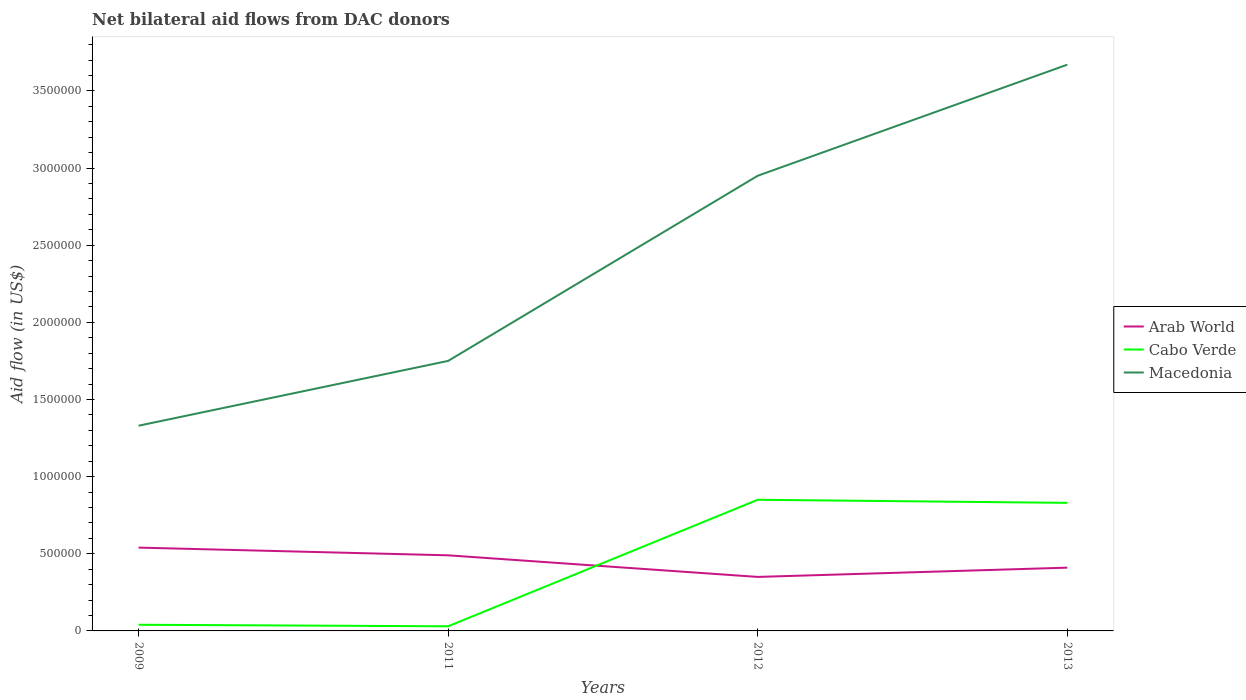How many different coloured lines are there?
Your response must be concise. 3. Does the line corresponding to Cabo Verde intersect with the line corresponding to Arab World?
Keep it short and to the point. Yes. Is the number of lines equal to the number of legend labels?
Your response must be concise. Yes. Across all years, what is the maximum net bilateral aid flow in Macedonia?
Offer a terse response. 1.33e+06. What is the total net bilateral aid flow in Macedonia in the graph?
Your response must be concise. -2.34e+06. What is the difference between the highest and the second highest net bilateral aid flow in Cabo Verde?
Keep it short and to the point. 8.20e+05. Is the net bilateral aid flow in Cabo Verde strictly greater than the net bilateral aid flow in Arab World over the years?
Give a very brief answer. No. How many lines are there?
Provide a succinct answer. 3. How many years are there in the graph?
Provide a succinct answer. 4. Are the values on the major ticks of Y-axis written in scientific E-notation?
Offer a very short reply. No. Where does the legend appear in the graph?
Your response must be concise. Center right. How many legend labels are there?
Your answer should be compact. 3. What is the title of the graph?
Provide a short and direct response. Net bilateral aid flows from DAC donors. What is the label or title of the X-axis?
Provide a succinct answer. Years. What is the label or title of the Y-axis?
Provide a succinct answer. Aid flow (in US$). What is the Aid flow (in US$) of Arab World in 2009?
Your response must be concise. 5.40e+05. What is the Aid flow (in US$) of Macedonia in 2009?
Provide a short and direct response. 1.33e+06. What is the Aid flow (in US$) of Arab World in 2011?
Ensure brevity in your answer.  4.90e+05. What is the Aid flow (in US$) of Macedonia in 2011?
Provide a short and direct response. 1.75e+06. What is the Aid flow (in US$) of Arab World in 2012?
Ensure brevity in your answer.  3.50e+05. What is the Aid flow (in US$) in Cabo Verde in 2012?
Provide a succinct answer. 8.50e+05. What is the Aid flow (in US$) in Macedonia in 2012?
Make the answer very short. 2.95e+06. What is the Aid flow (in US$) of Cabo Verde in 2013?
Your answer should be compact. 8.30e+05. What is the Aid flow (in US$) of Macedonia in 2013?
Keep it short and to the point. 3.67e+06. Across all years, what is the maximum Aid flow (in US$) of Arab World?
Your response must be concise. 5.40e+05. Across all years, what is the maximum Aid flow (in US$) of Cabo Verde?
Your answer should be compact. 8.50e+05. Across all years, what is the maximum Aid flow (in US$) of Macedonia?
Keep it short and to the point. 3.67e+06. Across all years, what is the minimum Aid flow (in US$) in Arab World?
Your answer should be very brief. 3.50e+05. Across all years, what is the minimum Aid flow (in US$) in Cabo Verde?
Provide a succinct answer. 3.00e+04. Across all years, what is the minimum Aid flow (in US$) of Macedonia?
Keep it short and to the point. 1.33e+06. What is the total Aid flow (in US$) in Arab World in the graph?
Your answer should be very brief. 1.79e+06. What is the total Aid flow (in US$) in Cabo Verde in the graph?
Provide a short and direct response. 1.75e+06. What is the total Aid flow (in US$) in Macedonia in the graph?
Make the answer very short. 9.70e+06. What is the difference between the Aid flow (in US$) of Arab World in 2009 and that in 2011?
Your response must be concise. 5.00e+04. What is the difference between the Aid flow (in US$) of Cabo Verde in 2009 and that in 2011?
Your answer should be very brief. 10000. What is the difference between the Aid flow (in US$) in Macedonia in 2009 and that in 2011?
Your answer should be compact. -4.20e+05. What is the difference between the Aid flow (in US$) in Arab World in 2009 and that in 2012?
Provide a succinct answer. 1.90e+05. What is the difference between the Aid flow (in US$) of Cabo Verde in 2009 and that in 2012?
Ensure brevity in your answer.  -8.10e+05. What is the difference between the Aid flow (in US$) of Macedonia in 2009 and that in 2012?
Provide a short and direct response. -1.62e+06. What is the difference between the Aid flow (in US$) in Arab World in 2009 and that in 2013?
Your answer should be very brief. 1.30e+05. What is the difference between the Aid flow (in US$) in Cabo Verde in 2009 and that in 2013?
Your answer should be very brief. -7.90e+05. What is the difference between the Aid flow (in US$) of Macedonia in 2009 and that in 2013?
Ensure brevity in your answer.  -2.34e+06. What is the difference between the Aid flow (in US$) in Cabo Verde in 2011 and that in 2012?
Make the answer very short. -8.20e+05. What is the difference between the Aid flow (in US$) of Macedonia in 2011 and that in 2012?
Keep it short and to the point. -1.20e+06. What is the difference between the Aid flow (in US$) in Arab World in 2011 and that in 2013?
Ensure brevity in your answer.  8.00e+04. What is the difference between the Aid flow (in US$) of Cabo Verde in 2011 and that in 2013?
Give a very brief answer. -8.00e+05. What is the difference between the Aid flow (in US$) in Macedonia in 2011 and that in 2013?
Keep it short and to the point. -1.92e+06. What is the difference between the Aid flow (in US$) in Cabo Verde in 2012 and that in 2013?
Your response must be concise. 2.00e+04. What is the difference between the Aid flow (in US$) of Macedonia in 2012 and that in 2013?
Ensure brevity in your answer.  -7.20e+05. What is the difference between the Aid flow (in US$) of Arab World in 2009 and the Aid flow (in US$) of Cabo Verde in 2011?
Keep it short and to the point. 5.10e+05. What is the difference between the Aid flow (in US$) in Arab World in 2009 and the Aid flow (in US$) in Macedonia in 2011?
Offer a terse response. -1.21e+06. What is the difference between the Aid flow (in US$) in Cabo Verde in 2009 and the Aid flow (in US$) in Macedonia in 2011?
Your answer should be very brief. -1.71e+06. What is the difference between the Aid flow (in US$) of Arab World in 2009 and the Aid flow (in US$) of Cabo Verde in 2012?
Your answer should be very brief. -3.10e+05. What is the difference between the Aid flow (in US$) in Arab World in 2009 and the Aid flow (in US$) in Macedonia in 2012?
Give a very brief answer. -2.41e+06. What is the difference between the Aid flow (in US$) of Cabo Verde in 2009 and the Aid flow (in US$) of Macedonia in 2012?
Provide a succinct answer. -2.91e+06. What is the difference between the Aid flow (in US$) in Arab World in 2009 and the Aid flow (in US$) in Macedonia in 2013?
Offer a very short reply. -3.13e+06. What is the difference between the Aid flow (in US$) of Cabo Verde in 2009 and the Aid flow (in US$) of Macedonia in 2013?
Keep it short and to the point. -3.63e+06. What is the difference between the Aid flow (in US$) of Arab World in 2011 and the Aid flow (in US$) of Cabo Verde in 2012?
Your response must be concise. -3.60e+05. What is the difference between the Aid flow (in US$) in Arab World in 2011 and the Aid flow (in US$) in Macedonia in 2012?
Offer a terse response. -2.46e+06. What is the difference between the Aid flow (in US$) of Cabo Verde in 2011 and the Aid flow (in US$) of Macedonia in 2012?
Ensure brevity in your answer.  -2.92e+06. What is the difference between the Aid flow (in US$) in Arab World in 2011 and the Aid flow (in US$) in Cabo Verde in 2013?
Make the answer very short. -3.40e+05. What is the difference between the Aid flow (in US$) of Arab World in 2011 and the Aid flow (in US$) of Macedonia in 2013?
Your response must be concise. -3.18e+06. What is the difference between the Aid flow (in US$) in Cabo Verde in 2011 and the Aid flow (in US$) in Macedonia in 2013?
Your answer should be compact. -3.64e+06. What is the difference between the Aid flow (in US$) in Arab World in 2012 and the Aid flow (in US$) in Cabo Verde in 2013?
Offer a terse response. -4.80e+05. What is the difference between the Aid flow (in US$) in Arab World in 2012 and the Aid flow (in US$) in Macedonia in 2013?
Your response must be concise. -3.32e+06. What is the difference between the Aid flow (in US$) in Cabo Verde in 2012 and the Aid flow (in US$) in Macedonia in 2013?
Offer a very short reply. -2.82e+06. What is the average Aid flow (in US$) of Arab World per year?
Offer a terse response. 4.48e+05. What is the average Aid flow (in US$) in Cabo Verde per year?
Your answer should be very brief. 4.38e+05. What is the average Aid flow (in US$) of Macedonia per year?
Your answer should be compact. 2.42e+06. In the year 2009, what is the difference between the Aid flow (in US$) of Arab World and Aid flow (in US$) of Cabo Verde?
Make the answer very short. 5.00e+05. In the year 2009, what is the difference between the Aid flow (in US$) in Arab World and Aid flow (in US$) in Macedonia?
Offer a very short reply. -7.90e+05. In the year 2009, what is the difference between the Aid flow (in US$) of Cabo Verde and Aid flow (in US$) of Macedonia?
Your answer should be compact. -1.29e+06. In the year 2011, what is the difference between the Aid flow (in US$) of Arab World and Aid flow (in US$) of Cabo Verde?
Your answer should be compact. 4.60e+05. In the year 2011, what is the difference between the Aid flow (in US$) of Arab World and Aid flow (in US$) of Macedonia?
Provide a short and direct response. -1.26e+06. In the year 2011, what is the difference between the Aid flow (in US$) of Cabo Verde and Aid flow (in US$) of Macedonia?
Ensure brevity in your answer.  -1.72e+06. In the year 2012, what is the difference between the Aid flow (in US$) in Arab World and Aid flow (in US$) in Cabo Verde?
Make the answer very short. -5.00e+05. In the year 2012, what is the difference between the Aid flow (in US$) in Arab World and Aid flow (in US$) in Macedonia?
Your answer should be compact. -2.60e+06. In the year 2012, what is the difference between the Aid flow (in US$) of Cabo Verde and Aid flow (in US$) of Macedonia?
Your answer should be compact. -2.10e+06. In the year 2013, what is the difference between the Aid flow (in US$) in Arab World and Aid flow (in US$) in Cabo Verde?
Your answer should be compact. -4.20e+05. In the year 2013, what is the difference between the Aid flow (in US$) in Arab World and Aid flow (in US$) in Macedonia?
Your answer should be compact. -3.26e+06. In the year 2013, what is the difference between the Aid flow (in US$) of Cabo Verde and Aid flow (in US$) of Macedonia?
Your answer should be compact. -2.84e+06. What is the ratio of the Aid flow (in US$) of Arab World in 2009 to that in 2011?
Your response must be concise. 1.1. What is the ratio of the Aid flow (in US$) of Macedonia in 2009 to that in 2011?
Ensure brevity in your answer.  0.76. What is the ratio of the Aid flow (in US$) in Arab World in 2009 to that in 2012?
Make the answer very short. 1.54. What is the ratio of the Aid flow (in US$) of Cabo Verde in 2009 to that in 2012?
Provide a short and direct response. 0.05. What is the ratio of the Aid flow (in US$) in Macedonia in 2009 to that in 2012?
Provide a succinct answer. 0.45. What is the ratio of the Aid flow (in US$) of Arab World in 2009 to that in 2013?
Your answer should be compact. 1.32. What is the ratio of the Aid flow (in US$) in Cabo Verde in 2009 to that in 2013?
Ensure brevity in your answer.  0.05. What is the ratio of the Aid flow (in US$) in Macedonia in 2009 to that in 2013?
Give a very brief answer. 0.36. What is the ratio of the Aid flow (in US$) in Arab World in 2011 to that in 2012?
Your answer should be very brief. 1.4. What is the ratio of the Aid flow (in US$) in Cabo Verde in 2011 to that in 2012?
Offer a very short reply. 0.04. What is the ratio of the Aid flow (in US$) in Macedonia in 2011 to that in 2012?
Your answer should be compact. 0.59. What is the ratio of the Aid flow (in US$) of Arab World in 2011 to that in 2013?
Give a very brief answer. 1.2. What is the ratio of the Aid flow (in US$) of Cabo Verde in 2011 to that in 2013?
Give a very brief answer. 0.04. What is the ratio of the Aid flow (in US$) of Macedonia in 2011 to that in 2013?
Your answer should be compact. 0.48. What is the ratio of the Aid flow (in US$) in Arab World in 2012 to that in 2013?
Your response must be concise. 0.85. What is the ratio of the Aid flow (in US$) of Cabo Verde in 2012 to that in 2013?
Make the answer very short. 1.02. What is the ratio of the Aid flow (in US$) in Macedonia in 2012 to that in 2013?
Give a very brief answer. 0.8. What is the difference between the highest and the second highest Aid flow (in US$) of Macedonia?
Keep it short and to the point. 7.20e+05. What is the difference between the highest and the lowest Aid flow (in US$) of Cabo Verde?
Offer a very short reply. 8.20e+05. What is the difference between the highest and the lowest Aid flow (in US$) of Macedonia?
Ensure brevity in your answer.  2.34e+06. 